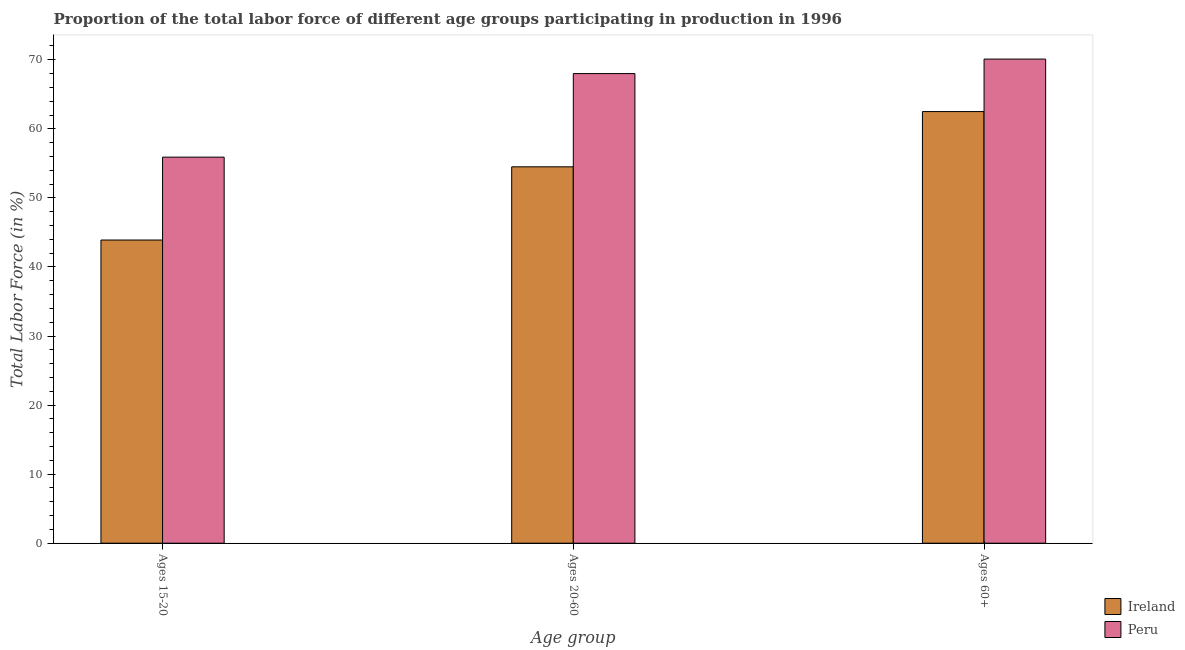Are the number of bars on each tick of the X-axis equal?
Give a very brief answer. Yes. How many bars are there on the 1st tick from the right?
Make the answer very short. 2. What is the label of the 3rd group of bars from the left?
Give a very brief answer. Ages 60+. What is the percentage of labor force within the age group 20-60 in Ireland?
Keep it short and to the point. 54.5. Across all countries, what is the minimum percentage of labor force within the age group 20-60?
Ensure brevity in your answer.  54.5. In which country was the percentage of labor force above age 60 maximum?
Provide a short and direct response. Peru. In which country was the percentage of labor force above age 60 minimum?
Offer a terse response. Ireland. What is the total percentage of labor force above age 60 in the graph?
Provide a succinct answer. 132.6. What is the difference between the percentage of labor force above age 60 in Peru and the percentage of labor force within the age group 15-20 in Ireland?
Keep it short and to the point. 26.2. What is the average percentage of labor force above age 60 per country?
Ensure brevity in your answer.  66.3. What is the difference between the percentage of labor force within the age group 15-20 and percentage of labor force above age 60 in Ireland?
Provide a succinct answer. -18.6. What is the ratio of the percentage of labor force within the age group 15-20 in Peru to that in Ireland?
Your response must be concise. 1.27. Is the percentage of labor force above age 60 in Peru less than that in Ireland?
Your answer should be compact. No. What is the difference between the highest and the second highest percentage of labor force above age 60?
Provide a succinct answer. 7.6. What is the difference between the highest and the lowest percentage of labor force within the age group 15-20?
Your answer should be compact. 12. What does the 1st bar from the left in Ages 15-20 represents?
Provide a short and direct response. Ireland. What does the 2nd bar from the right in Ages 15-20 represents?
Ensure brevity in your answer.  Ireland. Is it the case that in every country, the sum of the percentage of labor force within the age group 15-20 and percentage of labor force within the age group 20-60 is greater than the percentage of labor force above age 60?
Give a very brief answer. Yes. How many countries are there in the graph?
Your answer should be very brief. 2. Does the graph contain any zero values?
Provide a short and direct response. No. Where does the legend appear in the graph?
Give a very brief answer. Bottom right. How many legend labels are there?
Provide a succinct answer. 2. What is the title of the graph?
Ensure brevity in your answer.  Proportion of the total labor force of different age groups participating in production in 1996. What is the label or title of the X-axis?
Provide a short and direct response. Age group. What is the label or title of the Y-axis?
Provide a short and direct response. Total Labor Force (in %). What is the Total Labor Force (in %) of Ireland in Ages 15-20?
Provide a succinct answer. 43.9. What is the Total Labor Force (in %) of Peru in Ages 15-20?
Make the answer very short. 55.9. What is the Total Labor Force (in %) of Ireland in Ages 20-60?
Your answer should be compact. 54.5. What is the Total Labor Force (in %) in Peru in Ages 20-60?
Ensure brevity in your answer.  68. What is the Total Labor Force (in %) of Ireland in Ages 60+?
Ensure brevity in your answer.  62.5. What is the Total Labor Force (in %) in Peru in Ages 60+?
Keep it short and to the point. 70.1. Across all Age group, what is the maximum Total Labor Force (in %) in Ireland?
Your answer should be very brief. 62.5. Across all Age group, what is the maximum Total Labor Force (in %) in Peru?
Ensure brevity in your answer.  70.1. Across all Age group, what is the minimum Total Labor Force (in %) of Ireland?
Offer a terse response. 43.9. Across all Age group, what is the minimum Total Labor Force (in %) of Peru?
Offer a very short reply. 55.9. What is the total Total Labor Force (in %) of Ireland in the graph?
Ensure brevity in your answer.  160.9. What is the total Total Labor Force (in %) in Peru in the graph?
Provide a short and direct response. 194. What is the difference between the Total Labor Force (in %) of Ireland in Ages 15-20 and that in Ages 20-60?
Provide a succinct answer. -10.6. What is the difference between the Total Labor Force (in %) of Ireland in Ages 15-20 and that in Ages 60+?
Offer a terse response. -18.6. What is the difference between the Total Labor Force (in %) of Ireland in Ages 20-60 and that in Ages 60+?
Give a very brief answer. -8. What is the difference between the Total Labor Force (in %) in Peru in Ages 20-60 and that in Ages 60+?
Provide a short and direct response. -2.1. What is the difference between the Total Labor Force (in %) in Ireland in Ages 15-20 and the Total Labor Force (in %) in Peru in Ages 20-60?
Your answer should be compact. -24.1. What is the difference between the Total Labor Force (in %) of Ireland in Ages 15-20 and the Total Labor Force (in %) of Peru in Ages 60+?
Your answer should be very brief. -26.2. What is the difference between the Total Labor Force (in %) of Ireland in Ages 20-60 and the Total Labor Force (in %) of Peru in Ages 60+?
Provide a short and direct response. -15.6. What is the average Total Labor Force (in %) of Ireland per Age group?
Make the answer very short. 53.63. What is the average Total Labor Force (in %) of Peru per Age group?
Offer a very short reply. 64.67. What is the difference between the Total Labor Force (in %) in Ireland and Total Labor Force (in %) in Peru in Ages 15-20?
Provide a succinct answer. -12. What is the ratio of the Total Labor Force (in %) in Ireland in Ages 15-20 to that in Ages 20-60?
Offer a very short reply. 0.81. What is the ratio of the Total Labor Force (in %) in Peru in Ages 15-20 to that in Ages 20-60?
Keep it short and to the point. 0.82. What is the ratio of the Total Labor Force (in %) in Ireland in Ages 15-20 to that in Ages 60+?
Give a very brief answer. 0.7. What is the ratio of the Total Labor Force (in %) of Peru in Ages 15-20 to that in Ages 60+?
Your answer should be compact. 0.8. What is the ratio of the Total Labor Force (in %) of Ireland in Ages 20-60 to that in Ages 60+?
Your answer should be very brief. 0.87. What is the ratio of the Total Labor Force (in %) in Peru in Ages 20-60 to that in Ages 60+?
Provide a succinct answer. 0.97. What is the difference between the highest and the second highest Total Labor Force (in %) in Peru?
Give a very brief answer. 2.1. What is the difference between the highest and the lowest Total Labor Force (in %) in Ireland?
Make the answer very short. 18.6. 